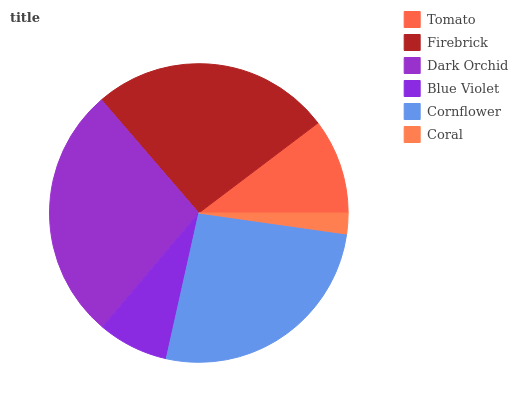Is Coral the minimum?
Answer yes or no. Yes. Is Dark Orchid the maximum?
Answer yes or no. Yes. Is Firebrick the minimum?
Answer yes or no. No. Is Firebrick the maximum?
Answer yes or no. No. Is Firebrick greater than Tomato?
Answer yes or no. Yes. Is Tomato less than Firebrick?
Answer yes or no. Yes. Is Tomato greater than Firebrick?
Answer yes or no. No. Is Firebrick less than Tomato?
Answer yes or no. No. Is Firebrick the high median?
Answer yes or no. Yes. Is Tomato the low median?
Answer yes or no. Yes. Is Cornflower the high median?
Answer yes or no. No. Is Coral the low median?
Answer yes or no. No. 